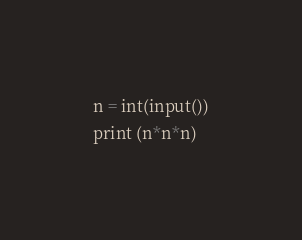Convert code to text. <code><loc_0><loc_0><loc_500><loc_500><_Python_>n = int(input())
print (n*n*n)</code> 